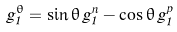Convert formula to latex. <formula><loc_0><loc_0><loc_500><loc_500>g _ { 1 } ^ { \theta } = \sin \theta \, g _ { 1 } ^ { n } - \cos \theta \, g _ { 1 } ^ { p }</formula> 